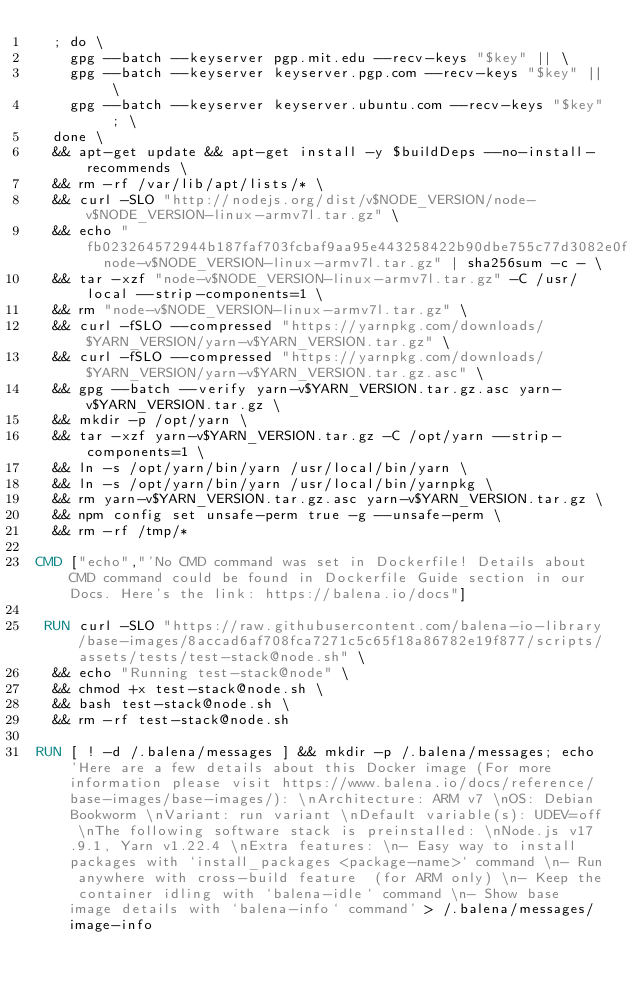<code> <loc_0><loc_0><loc_500><loc_500><_Dockerfile_>	; do \
		gpg --batch --keyserver pgp.mit.edu --recv-keys "$key" || \
		gpg --batch --keyserver keyserver.pgp.com --recv-keys "$key" || \
		gpg --batch --keyserver keyserver.ubuntu.com --recv-keys "$key" ; \
	done \
	&& apt-get update && apt-get install -y $buildDeps --no-install-recommends \
	&& rm -rf /var/lib/apt/lists/* \
	&& curl -SLO "http://nodejs.org/dist/v$NODE_VERSION/node-v$NODE_VERSION-linux-armv7l.tar.gz" \
	&& echo "fb023264572944b187faf703fcbaf9aa95e443258422b90dbe755c77d3082e0f  node-v$NODE_VERSION-linux-armv7l.tar.gz" | sha256sum -c - \
	&& tar -xzf "node-v$NODE_VERSION-linux-armv7l.tar.gz" -C /usr/local --strip-components=1 \
	&& rm "node-v$NODE_VERSION-linux-armv7l.tar.gz" \
	&& curl -fSLO --compressed "https://yarnpkg.com/downloads/$YARN_VERSION/yarn-v$YARN_VERSION.tar.gz" \
	&& curl -fSLO --compressed "https://yarnpkg.com/downloads/$YARN_VERSION/yarn-v$YARN_VERSION.tar.gz.asc" \
	&& gpg --batch --verify yarn-v$YARN_VERSION.tar.gz.asc yarn-v$YARN_VERSION.tar.gz \
	&& mkdir -p /opt/yarn \
	&& tar -xzf yarn-v$YARN_VERSION.tar.gz -C /opt/yarn --strip-components=1 \
	&& ln -s /opt/yarn/bin/yarn /usr/local/bin/yarn \
	&& ln -s /opt/yarn/bin/yarn /usr/local/bin/yarnpkg \
	&& rm yarn-v$YARN_VERSION.tar.gz.asc yarn-v$YARN_VERSION.tar.gz \
	&& npm config set unsafe-perm true -g --unsafe-perm \
	&& rm -rf /tmp/*

CMD ["echo","'No CMD command was set in Dockerfile! Details about CMD command could be found in Dockerfile Guide section in our Docs. Here's the link: https://balena.io/docs"]

 RUN curl -SLO "https://raw.githubusercontent.com/balena-io-library/base-images/8accad6af708fca7271c5c65f18a86782e19f877/scripts/assets/tests/test-stack@node.sh" \
  && echo "Running test-stack@node" \
  && chmod +x test-stack@node.sh \
  && bash test-stack@node.sh \
  && rm -rf test-stack@node.sh 

RUN [ ! -d /.balena/messages ] && mkdir -p /.balena/messages; echo 'Here are a few details about this Docker image (For more information please visit https://www.balena.io/docs/reference/base-images/base-images/): \nArchitecture: ARM v7 \nOS: Debian Bookworm \nVariant: run variant \nDefault variable(s): UDEV=off \nThe following software stack is preinstalled: \nNode.js v17.9.1, Yarn v1.22.4 \nExtra features: \n- Easy way to install packages with `install_packages <package-name>` command \n- Run anywhere with cross-build feature  (for ARM only) \n- Keep the container idling with `balena-idle` command \n- Show base image details with `balena-info` command' > /.balena/messages/image-info</code> 